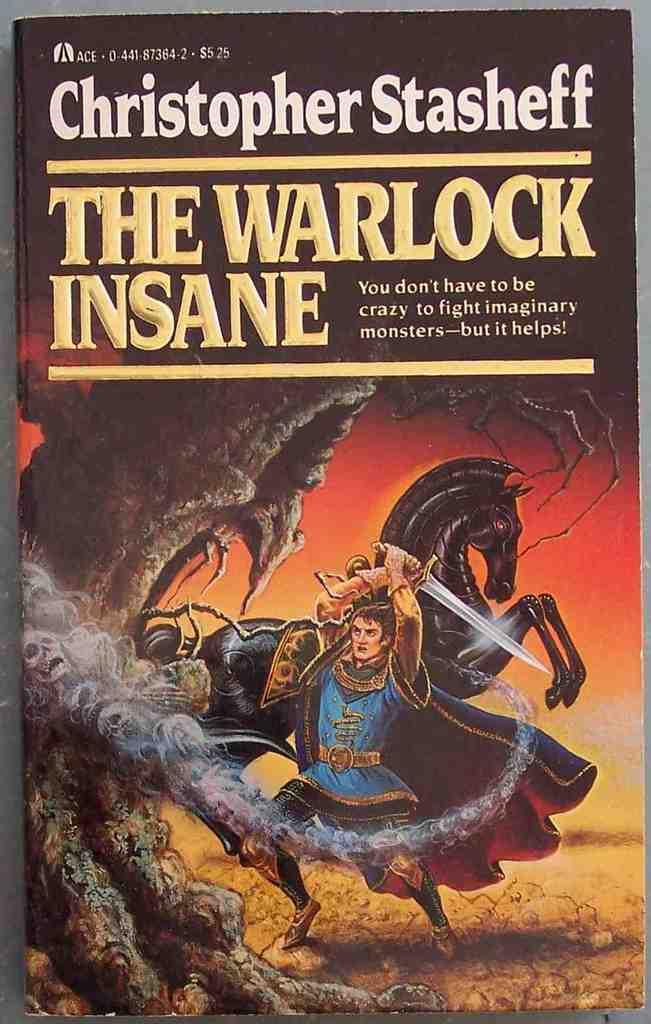What is the title?
Make the answer very short. The warlock insane. 